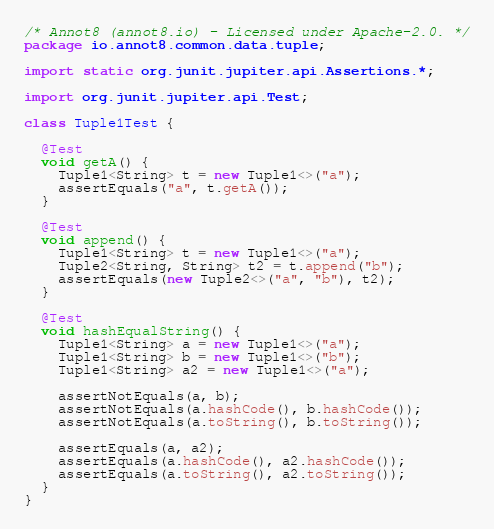<code> <loc_0><loc_0><loc_500><loc_500><_Java_>/* Annot8 (annot8.io) - Licensed under Apache-2.0. */
package io.annot8.common.data.tuple;

import static org.junit.jupiter.api.Assertions.*;

import org.junit.jupiter.api.Test;

class Tuple1Test {

  @Test
  void getA() {
    Tuple1<String> t = new Tuple1<>("a");
    assertEquals("a", t.getA());
  }

  @Test
  void append() {
    Tuple1<String> t = new Tuple1<>("a");
    Tuple2<String, String> t2 = t.append("b");
    assertEquals(new Tuple2<>("a", "b"), t2);
  }

  @Test
  void hashEqualString() {
    Tuple1<String> a = new Tuple1<>("a");
    Tuple1<String> b = new Tuple1<>("b");
    Tuple1<String> a2 = new Tuple1<>("a");

    assertNotEquals(a, b);
    assertNotEquals(a.hashCode(), b.hashCode());
    assertNotEquals(a.toString(), b.toString());

    assertEquals(a, a2);
    assertEquals(a.hashCode(), a2.hashCode());
    assertEquals(a.toString(), a2.toString());
  }
}
</code> 